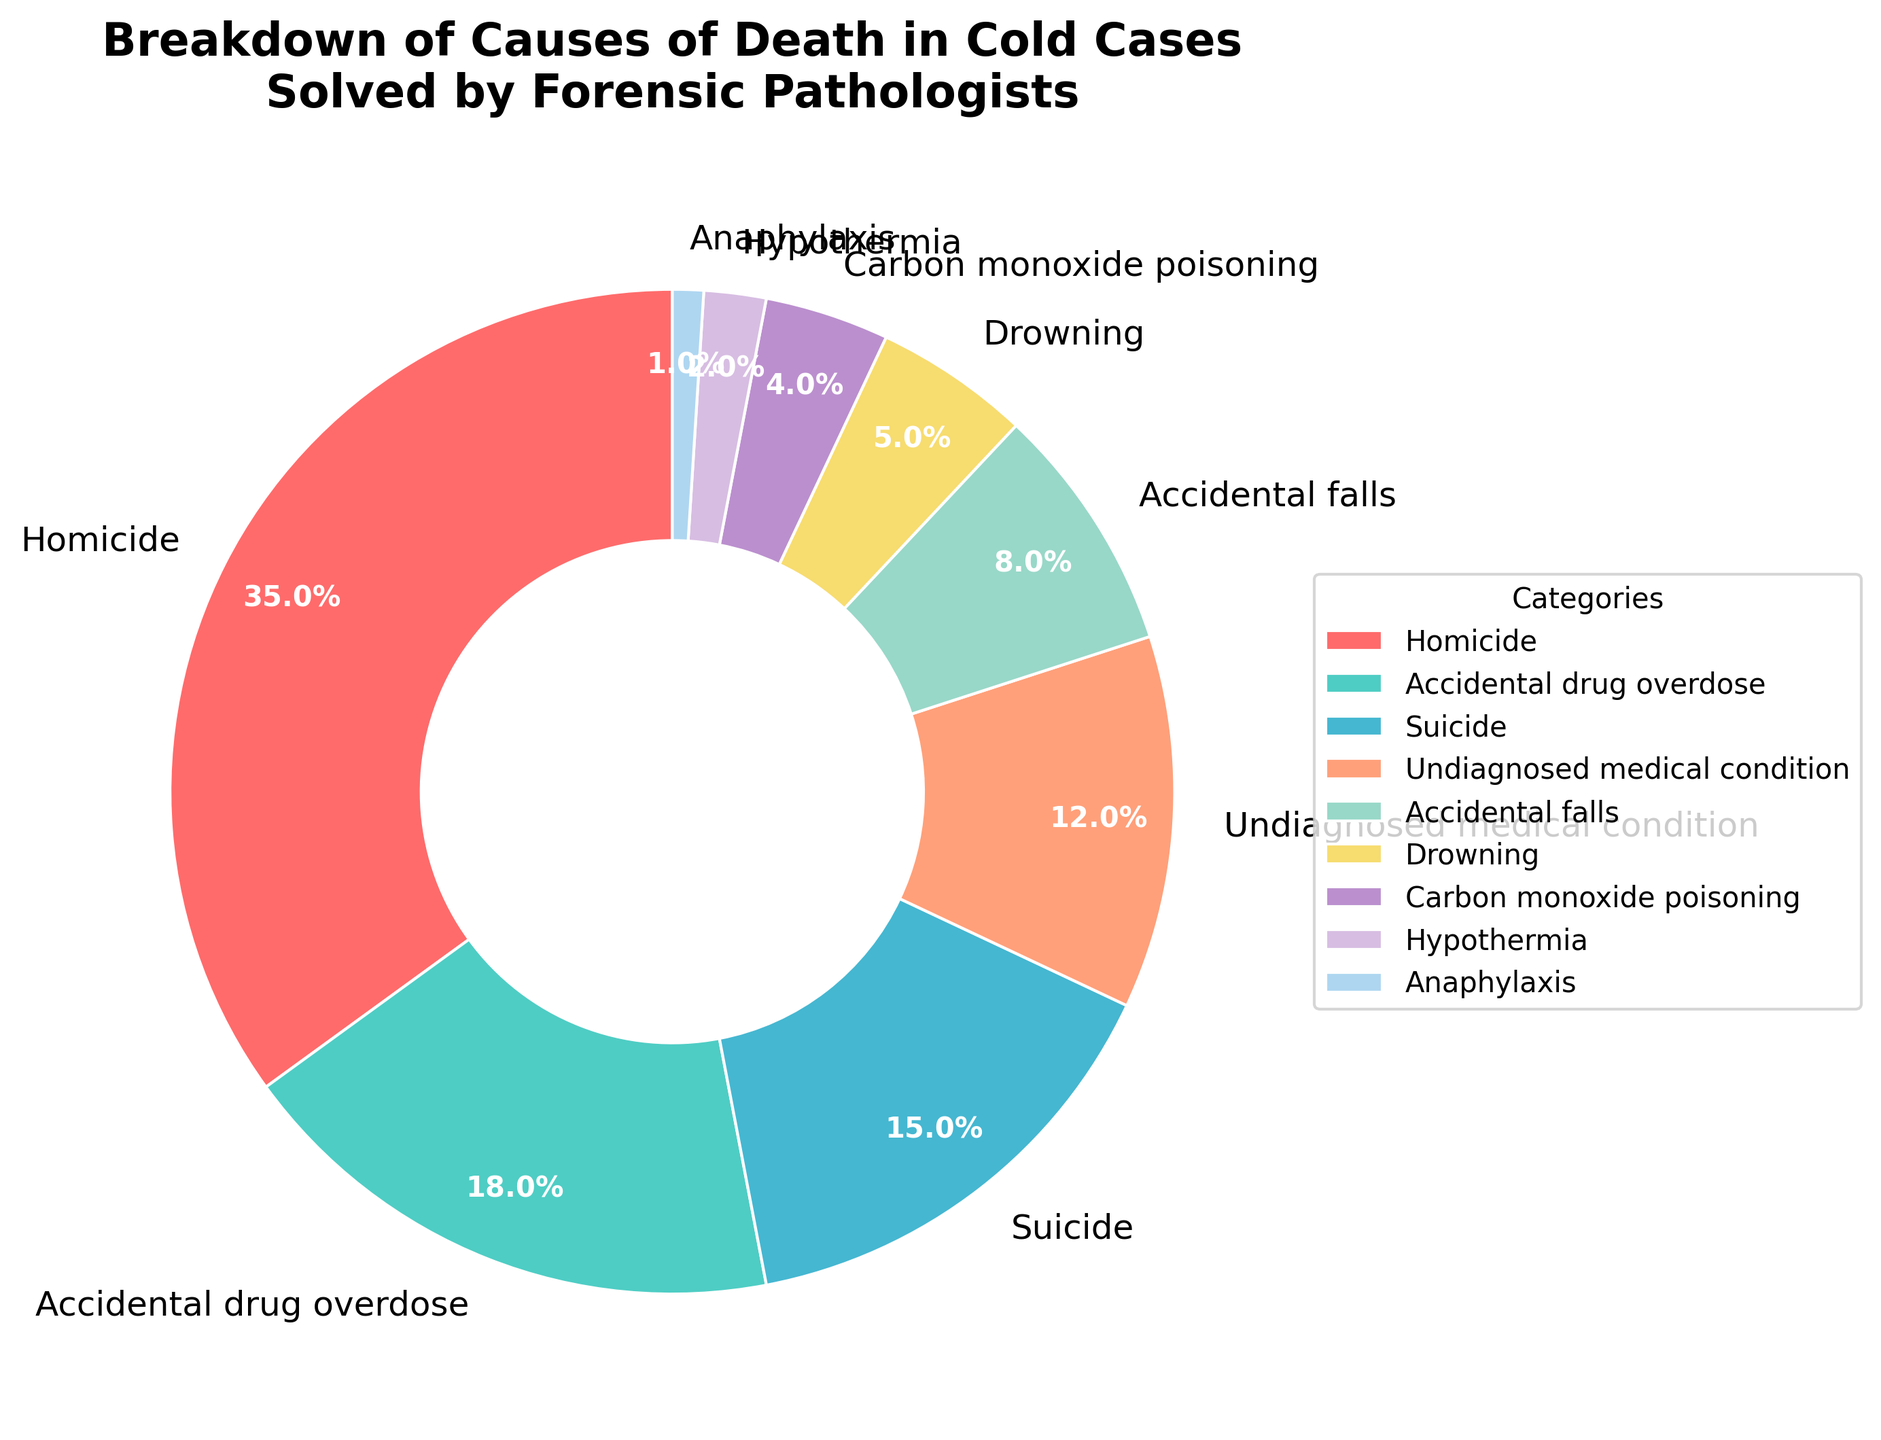What is the most common cause of death in cold cases solved by forensic pathologists? In the pie chart, the largest section represents the most common cause of death, which is labeled "Homicide"
Answer: Homicide How much more prevalent are homicides compared to accidental drug overdoses? The percentage for homicides is 35%, and for accidental drug overdoses, it's 18%. The difference is calculated as 35% - 18% = 17%
Answer: 17% What is the combined percentage of deaths caused by undiagnosed medical conditions and accidental falls? The percentage for undiagnosed medical conditions is 12%, and for accidental falls, it's 8%. The combined percentage is 12% + 8% = 20%
Answer: 20% Which cause of death has a smaller percentage: drowning or carbon monoxide poisoning? By looking at the pie chart, the section for drowning shows 5%, while carbon monoxide poisoning shows 4%. 4% is smaller than 5%
Answer: Carbon monoxide poisoning Which causes of death have a percentage less than 10%? By observing the pie chart, we can see that accidental falls (8%), drowning (5%), carbon monoxide poisoning (4%), hypothermia (2%), and anaphylaxis (1%) all have percentages less than 10%
Answer: Accidental falls, Drowning, Carbon monoxide poisoning, Hypothermia, Anaphylaxis How many categories represent causes of death that have a percentage greater than or equal to 15%? The categories with percentages greater than or equal to 15% are Homicide (35%), Accidental drug overdose (18%), and Suicide (15%). That accounts for 3 categories
Answer: 3 What is the total percentage for the least common three causes of death? The least common causes of death are hypothermia (2%), anaphylaxis (1%), and carbon monoxide poisoning (4%). Totaling these gives 2% + 1% + 4% = 7%
Answer: 7% Which section in the pie chart is represented by a green color? By inspecting the pie chart's colors, the green section represents "Accidental drug overdose"
Answer: Accidental drug overdose Is suicide more or less common than undiagnosed medical conditions according to the chart? The pie chart shows that suicide has a percentage of 15%, while undiagnosed medical conditions are at 12%. Therefore, suicide is more common than undiagnosed medical conditions
Answer: More common 